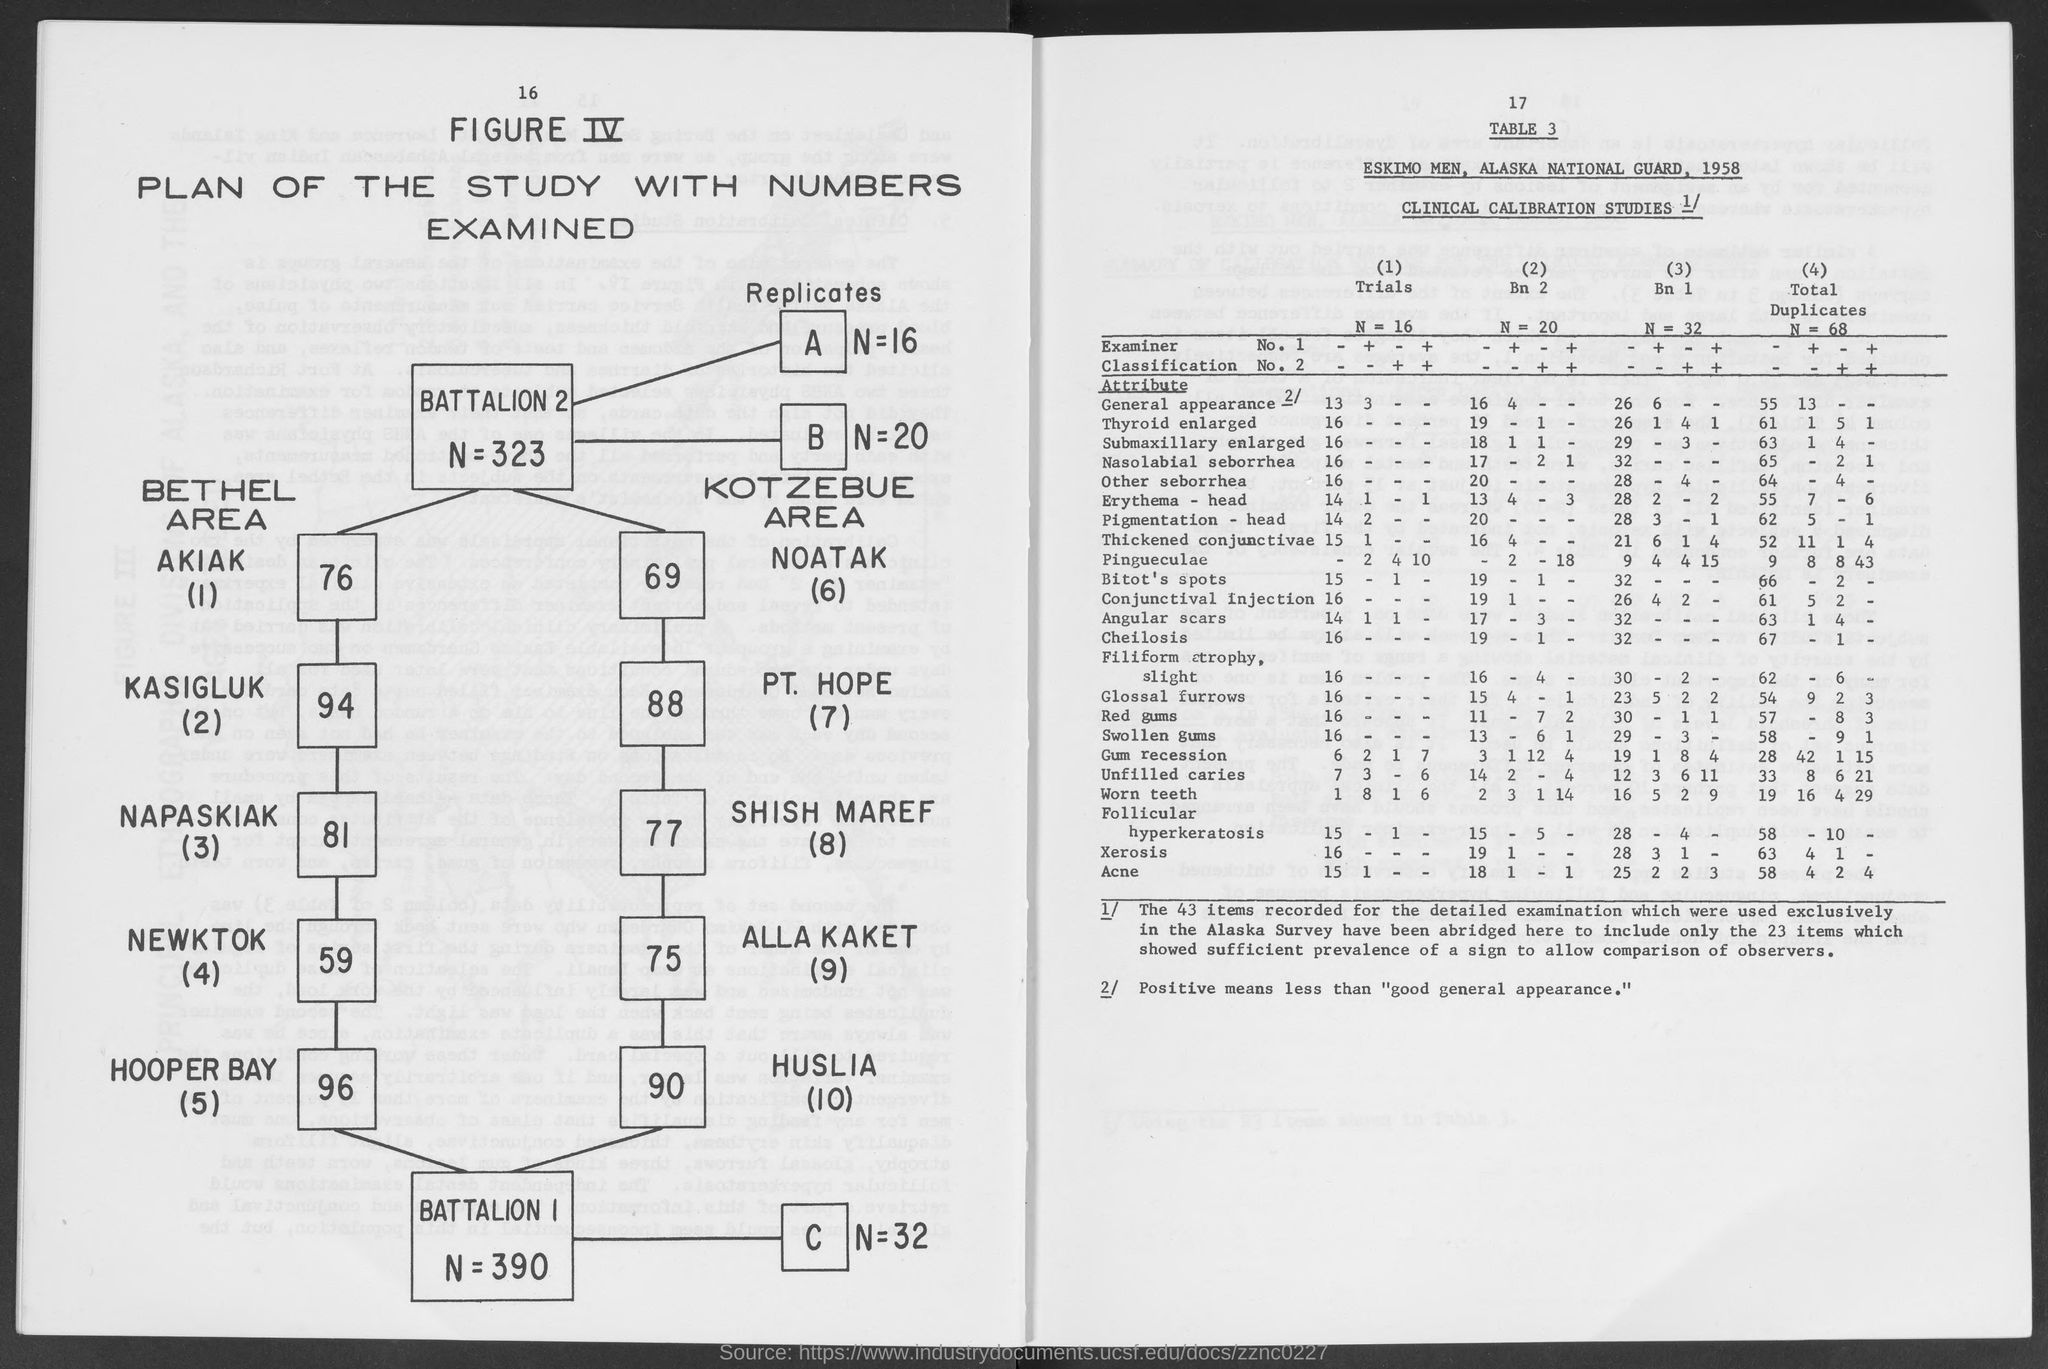Outline some significant characteristics in this image. Positive means less than what? Good general appearance. 